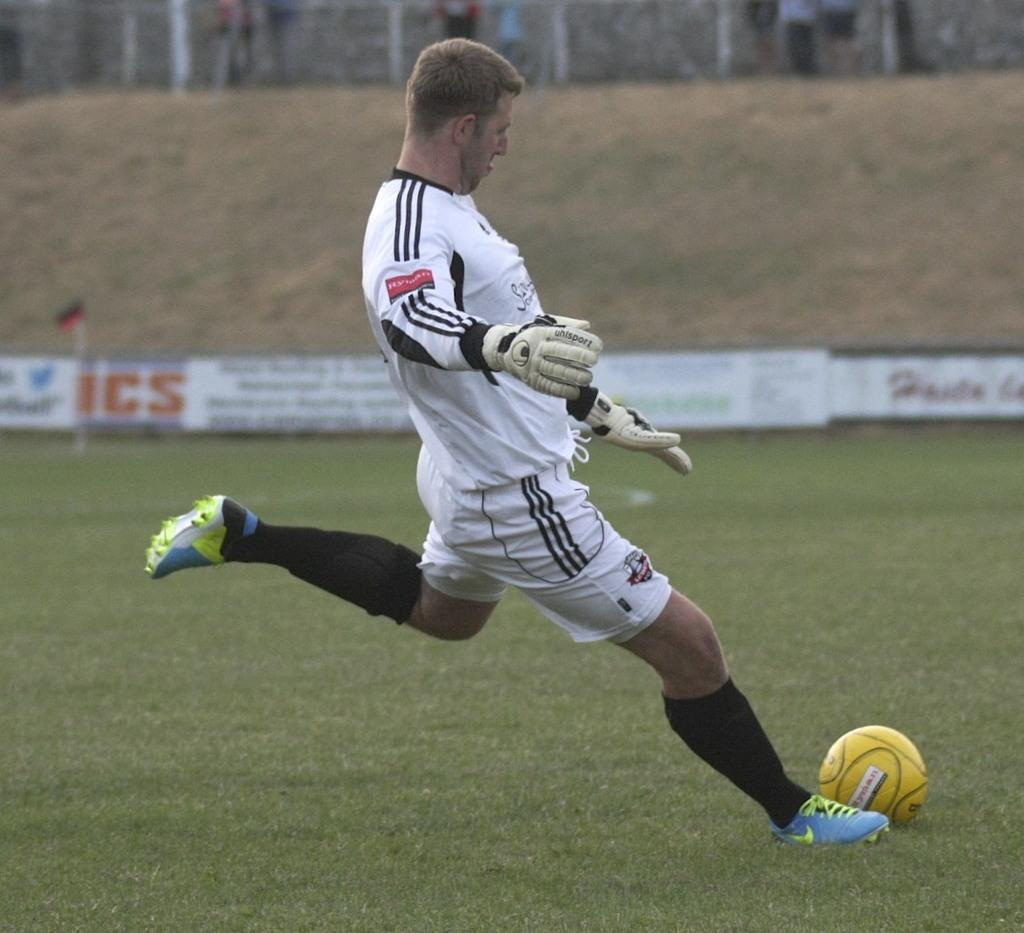What is the man in the image doing? The man is playing with a ball in the image. What can be seen in the background of the image? There is grass, boards, a group of people, and a flag with a pole in the background of the image. What type of sea creature can be seen swimming in the background of the image? There is no sea creature present in the image; it is set on a grassy area with a group of people and a flag with a pole in the background. 